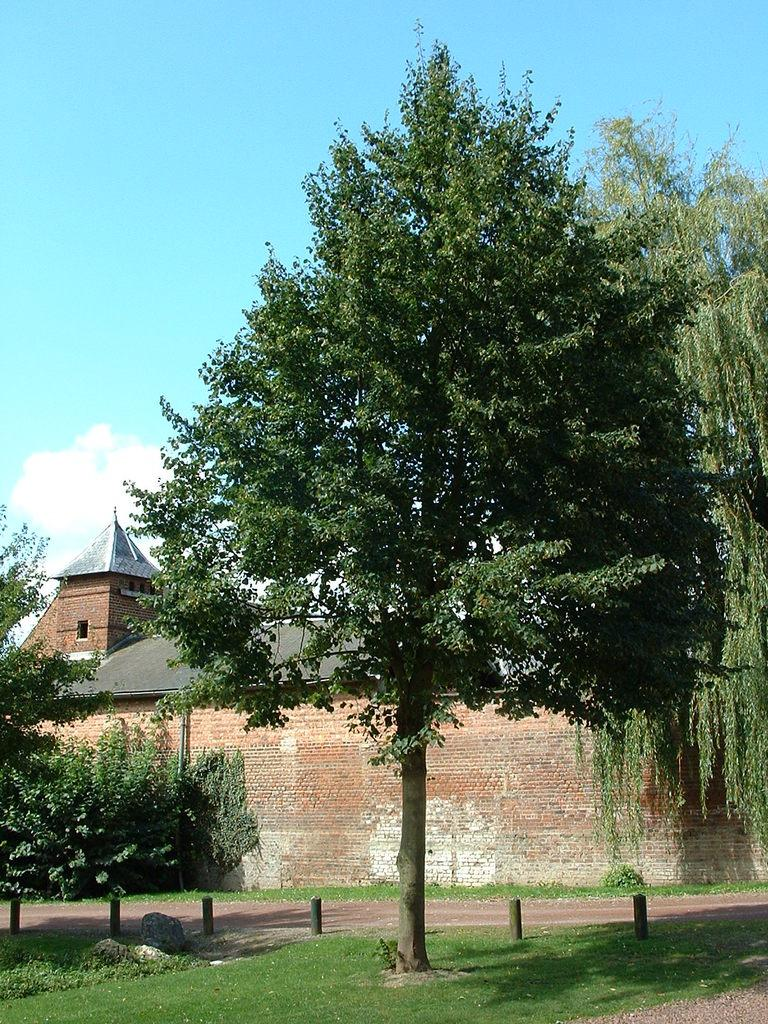What type of natural elements are present in the image? There are trees and plants in the image. What structure can be seen in the middle of the image? There is a shelter house in the middle of the image. What is visible at the top of the image? The sky is visible at the top of the image. Can you see your friend helping during the earthquake in the image? There is no reference to a friend or an earthquake in the image, so it is not possible to answer that question. 